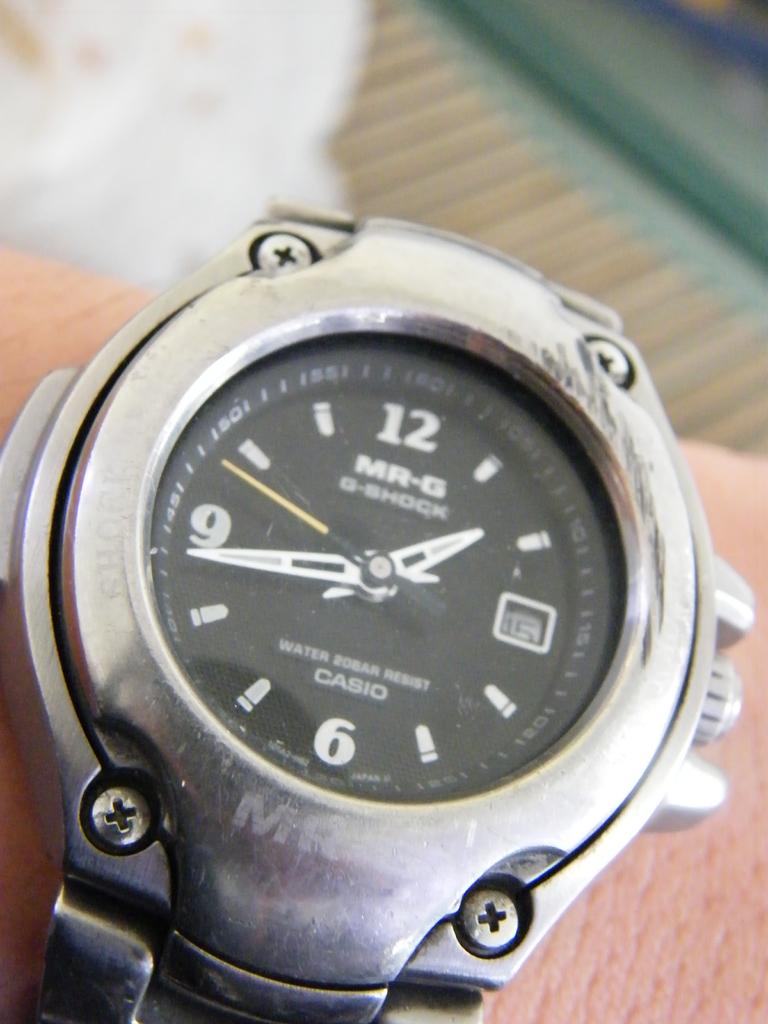What is the time displayed on the watch?
Provide a short and direct response. 1:43. What is the brand of this watch?
Provide a succinct answer. Casio. 